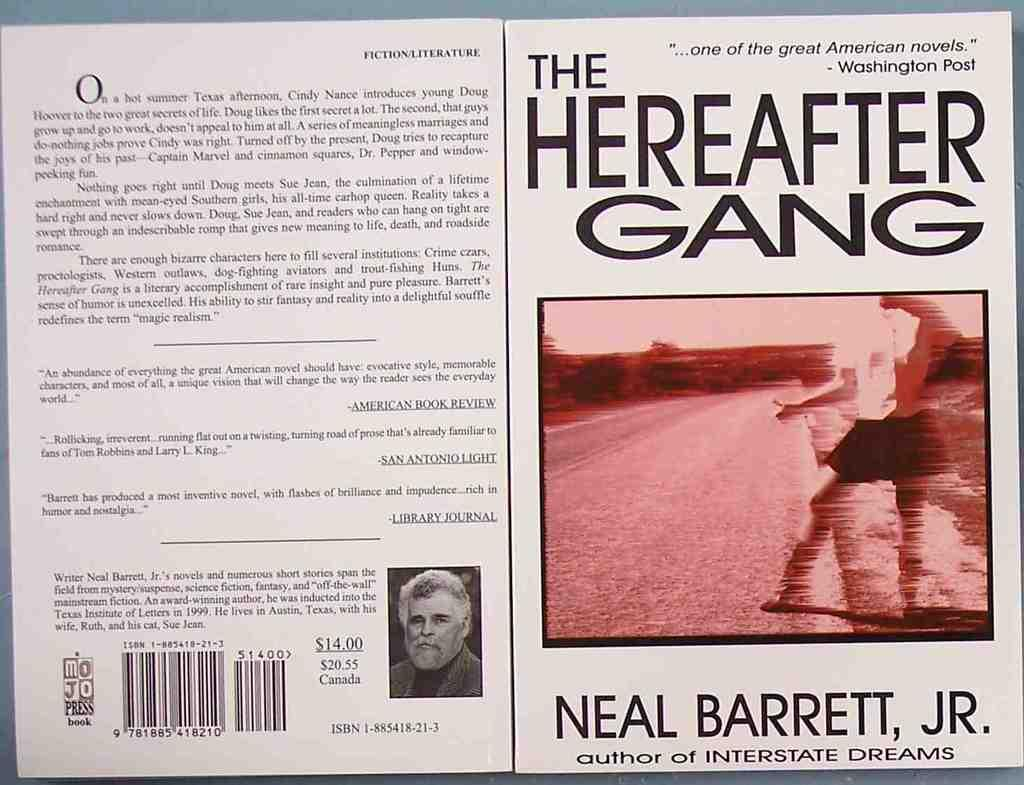<image>
Render a clear and concise summary of the photo. A copy of a book jacket for The Hereafter Gang by Neal Barrett, Jr lies on a table. 